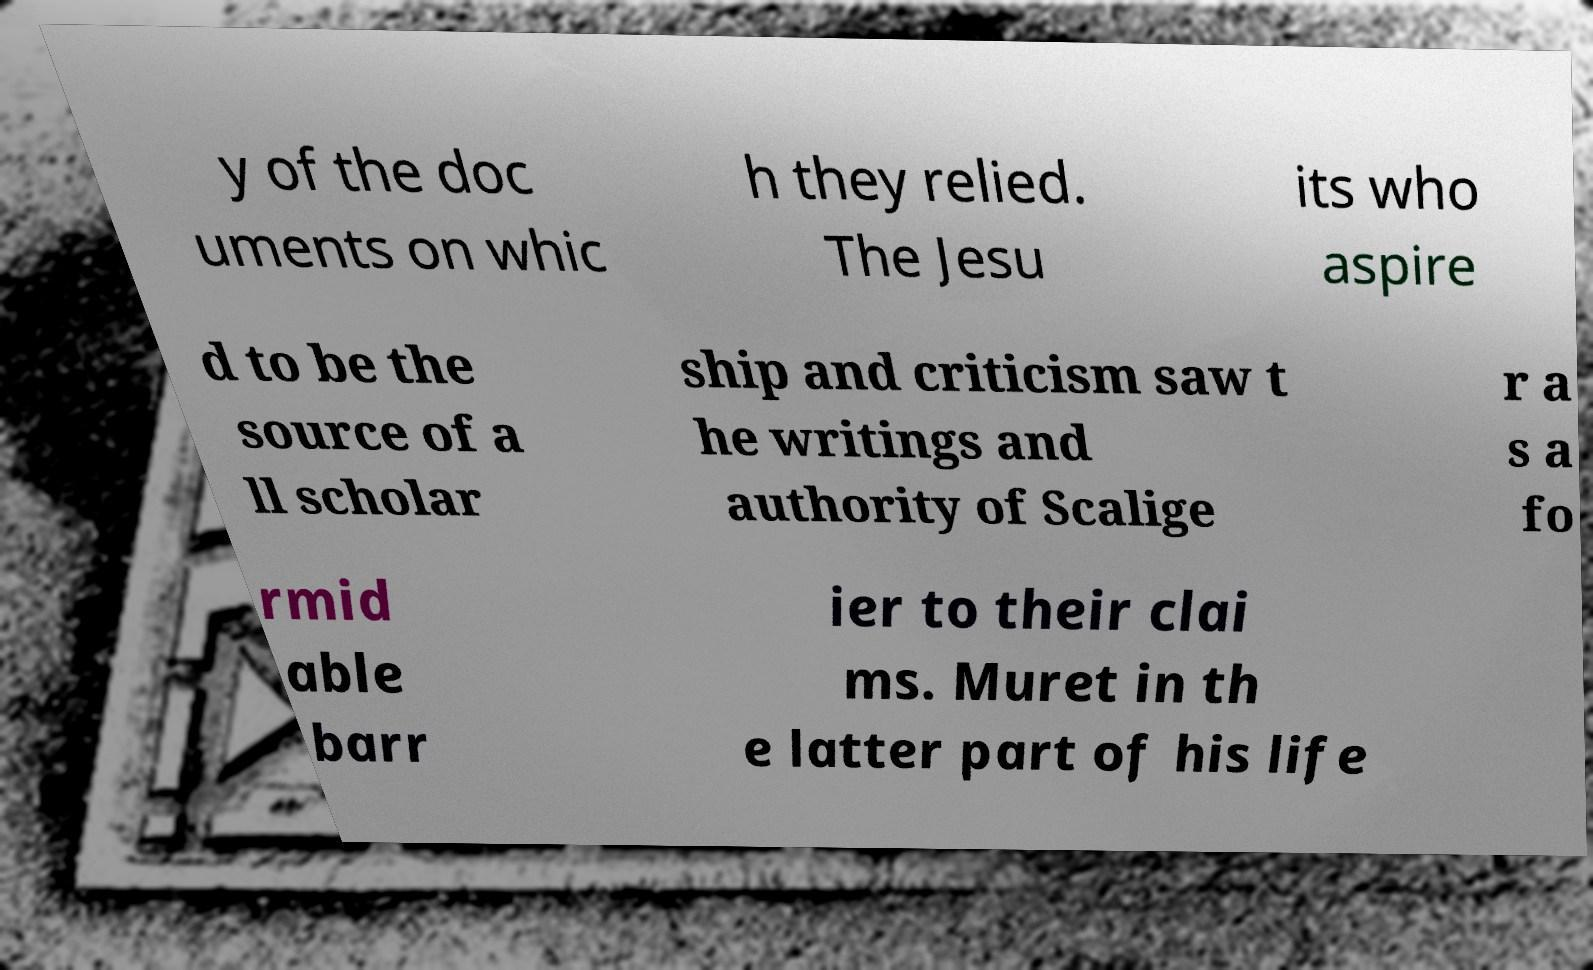Could you assist in decoding the text presented in this image and type it out clearly? y of the doc uments on whic h they relied. The Jesu its who aspire d to be the source of a ll scholar ship and criticism saw t he writings and authority of Scalige r a s a fo rmid able barr ier to their clai ms. Muret in th e latter part of his life 